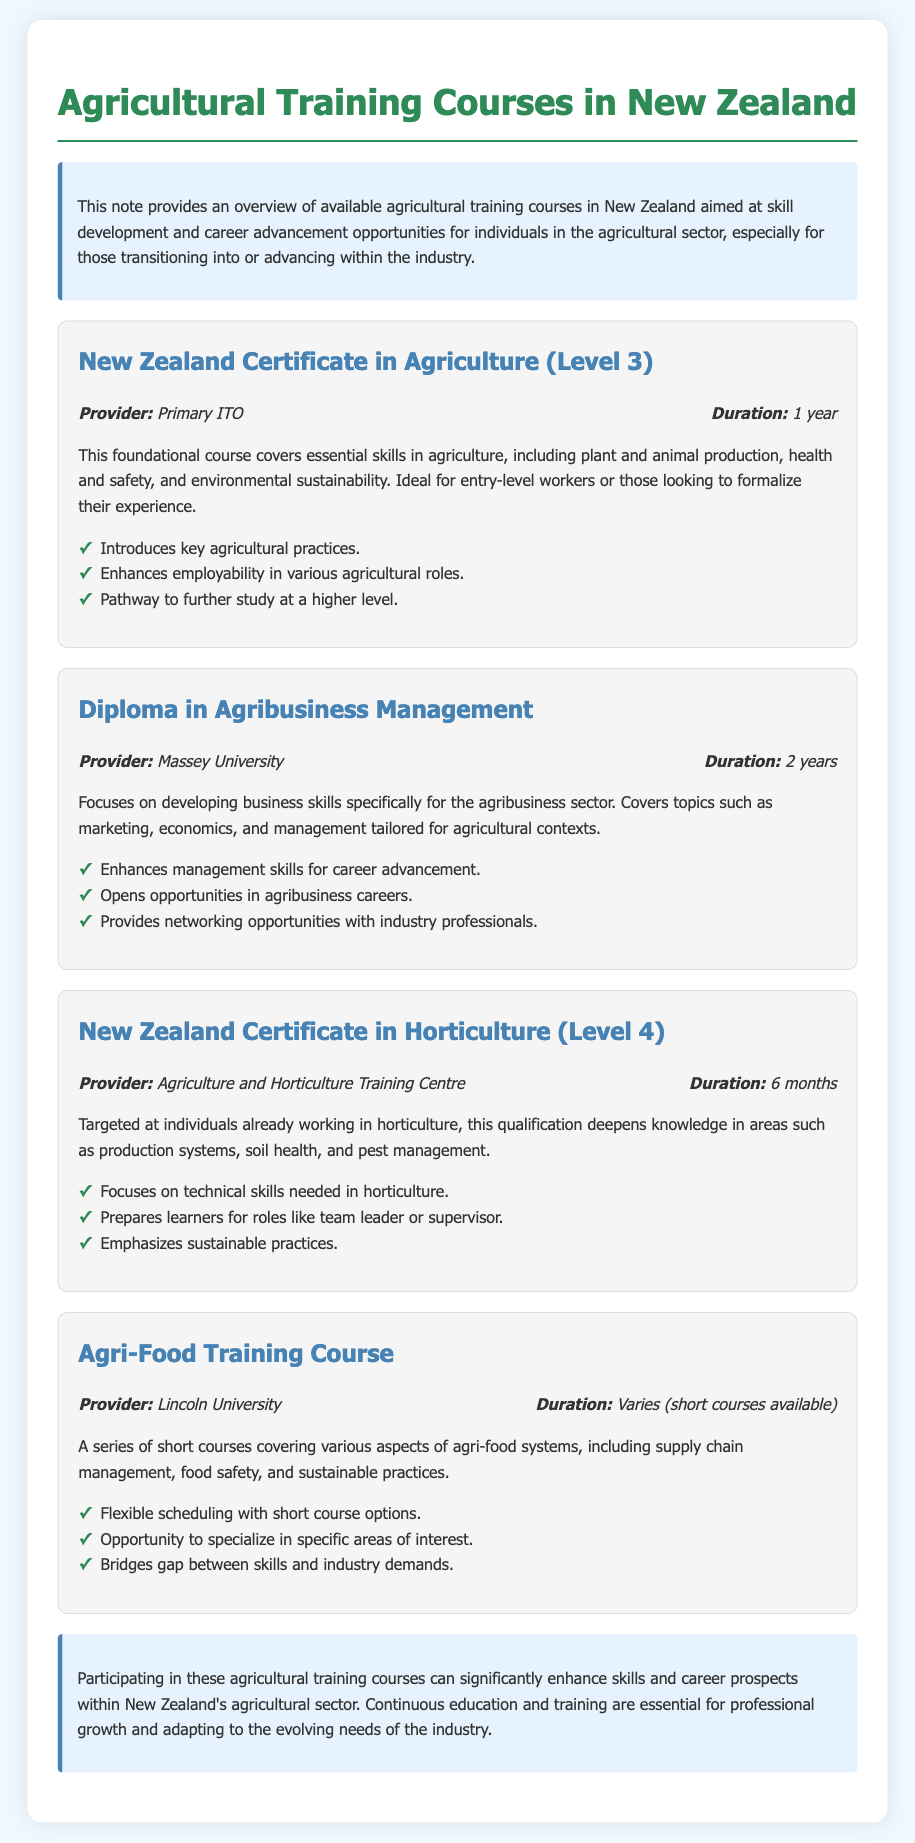What is the first course listed? The first course listed in the document is the New Zealand Certificate in Agriculture (Level 3).
Answer: New Zealand Certificate in Agriculture (Level 3) What is the duration of the Diploma in Agribusiness Management? The document states that the duration of the Diploma in Agribusiness Management is 2 years.
Answer: 2 years Which provider offers the New Zealand Certificate in Horticulture (Level 4)? The document specifies that the New Zealand Certificate in Horticulture (Level 4) is provided by the Agriculture and Horticulture Training Centre.
Answer: Agriculture and Horticulture Training Centre What is one benefit of the Agri-Food Training Course? The benefits listed include flexible scheduling with short course options.
Answer: Flexible scheduling with short course options How long is the New Zealand Certificate in Agriculture (Level 3)? The document indicates that the duration of the New Zealand Certificate in Agriculture (Level 3) is 1 year.
Answer: 1 year Which course prepares learners for roles like team leader or supervisor? According to the document, the New Zealand Certificate in Horticulture (Level 4) prepares learners for such roles.
Answer: New Zealand Certificate in Horticulture (Level 4) What type of courses does Lincoln University provide? Lincoln University offers a series of short courses covering various aspects of agri-food systems.
Answer: Short courses What is emphasized in the New Zealand Certificate in Horticulture (Level 4)? The document emphasizes sustainable practices in the New Zealand Certificate in Horticulture (Level 4).
Answer: Sustainable practices What is the focus of the Diploma in Agribusiness Management? The focus is on developing business skills specifically for the agribusiness sector.
Answer: Developing business skills specifically for the agribusiness sector 